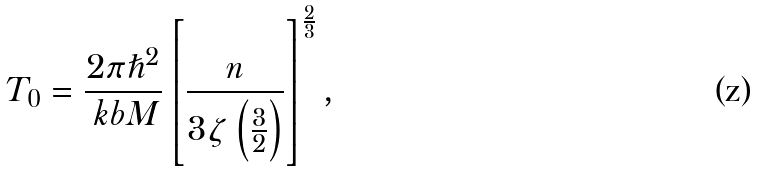<formula> <loc_0><loc_0><loc_500><loc_500>T _ { 0 } = \frac { 2 \pi \hslash ^ { 2 } } { \ k b M } \left [ \frac { n } { 3 \zeta \left ( \frac { 3 } { 2 } \right ) } \right ] ^ { \frac { 2 } { 3 } } ,</formula> 